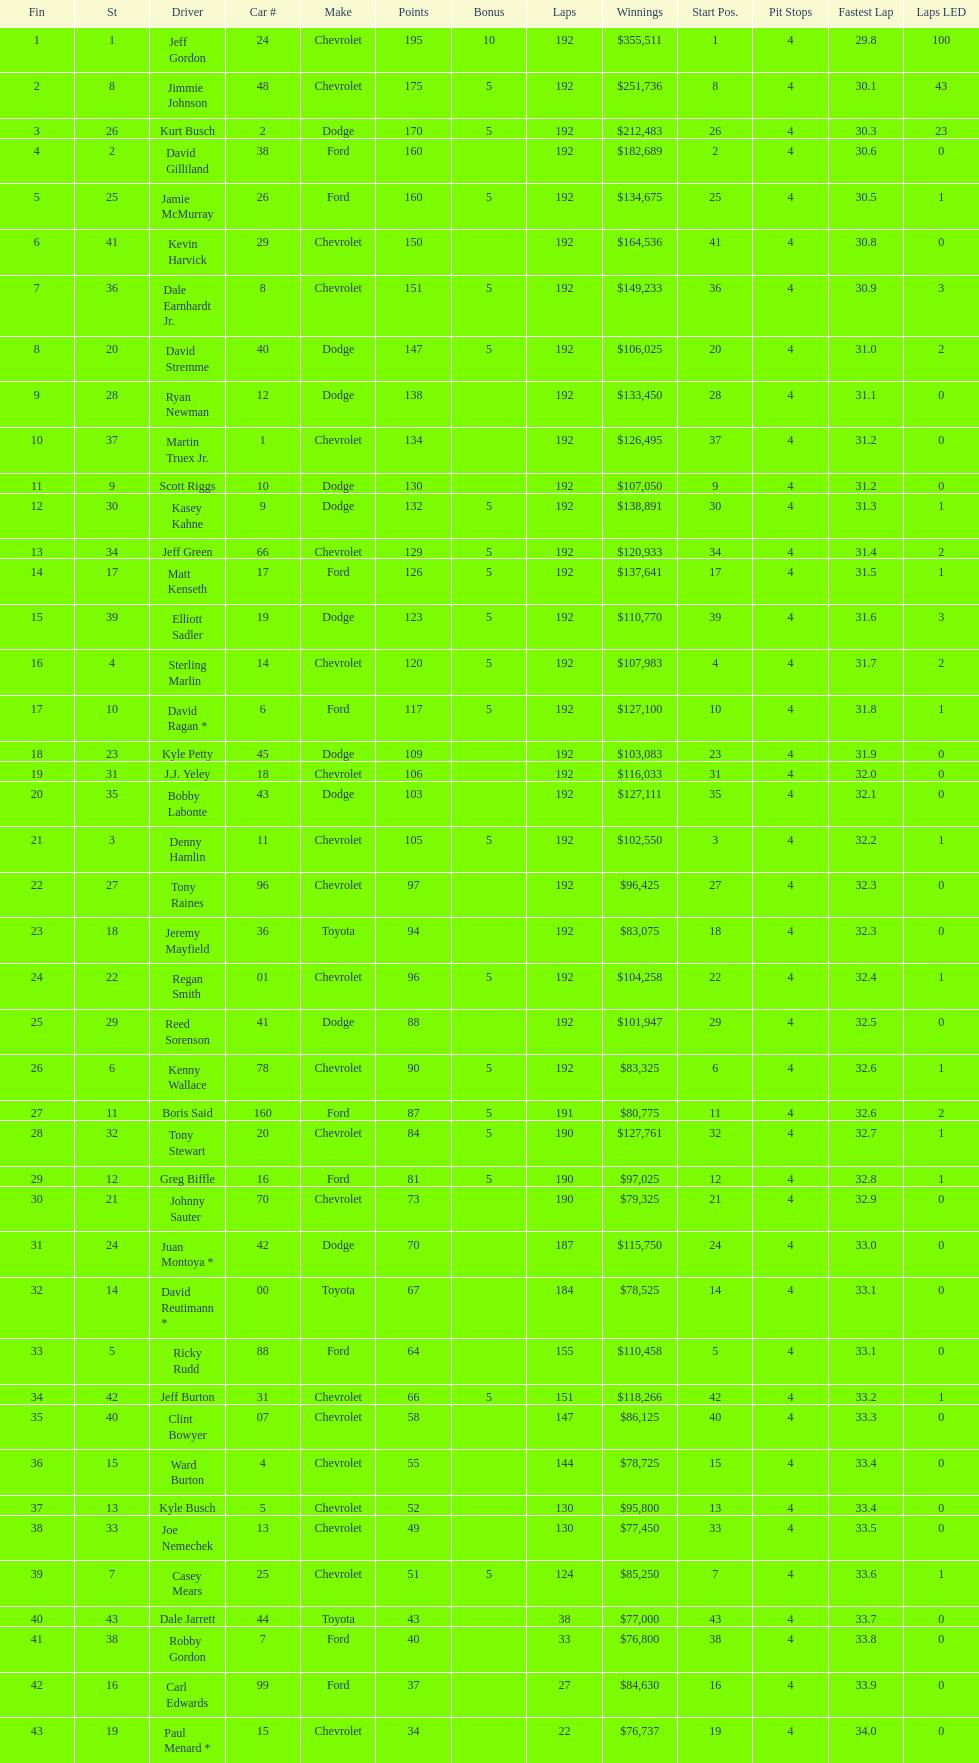Who is first in number of winnings on this list? Jeff Gordon. 